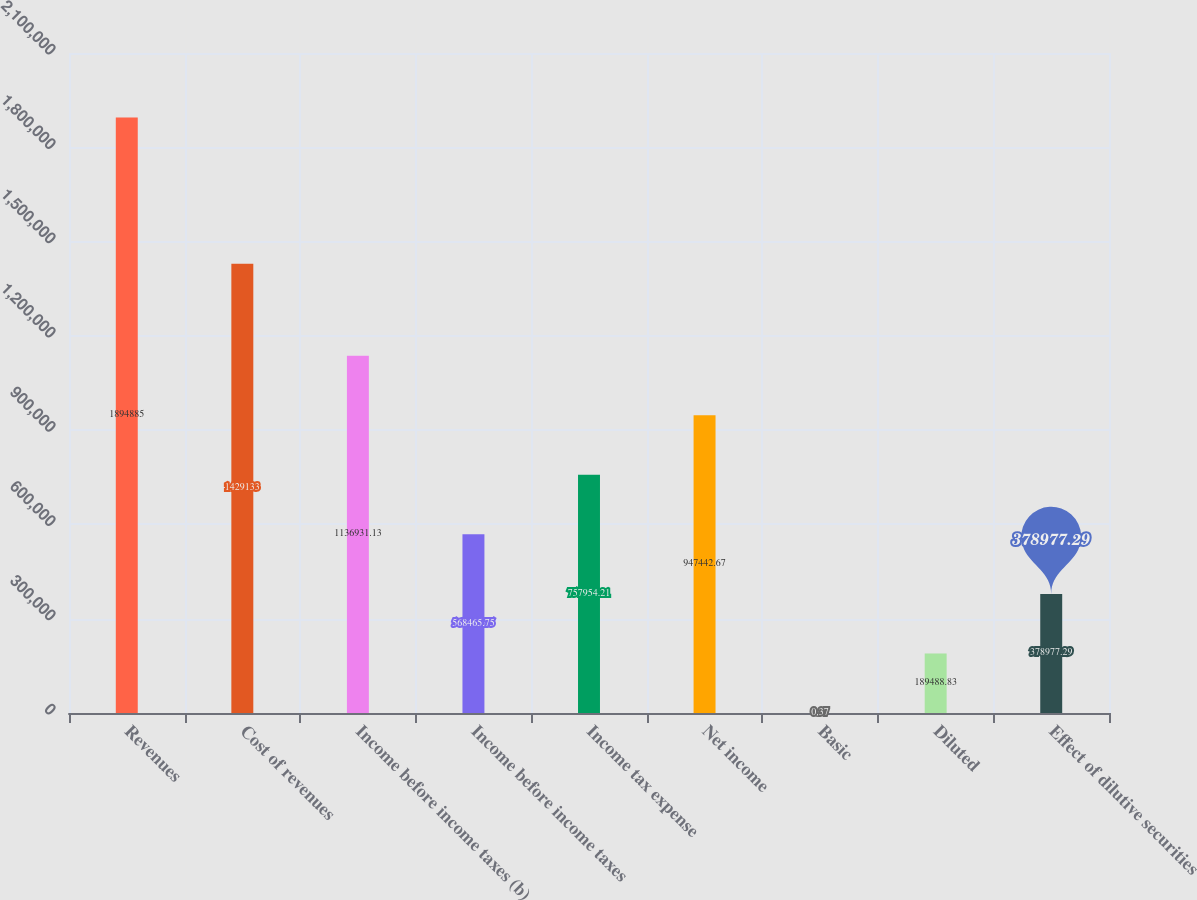Convert chart. <chart><loc_0><loc_0><loc_500><loc_500><bar_chart><fcel>Revenues<fcel>Cost of revenues<fcel>Income before income taxes (b)<fcel>Income before income taxes<fcel>Income tax expense<fcel>Net income<fcel>Basic<fcel>Diluted<fcel>Effect of dilutive securities<nl><fcel>1.89488e+06<fcel>1.42913e+06<fcel>1.13693e+06<fcel>568466<fcel>757954<fcel>947443<fcel>0.37<fcel>189489<fcel>378977<nl></chart> 